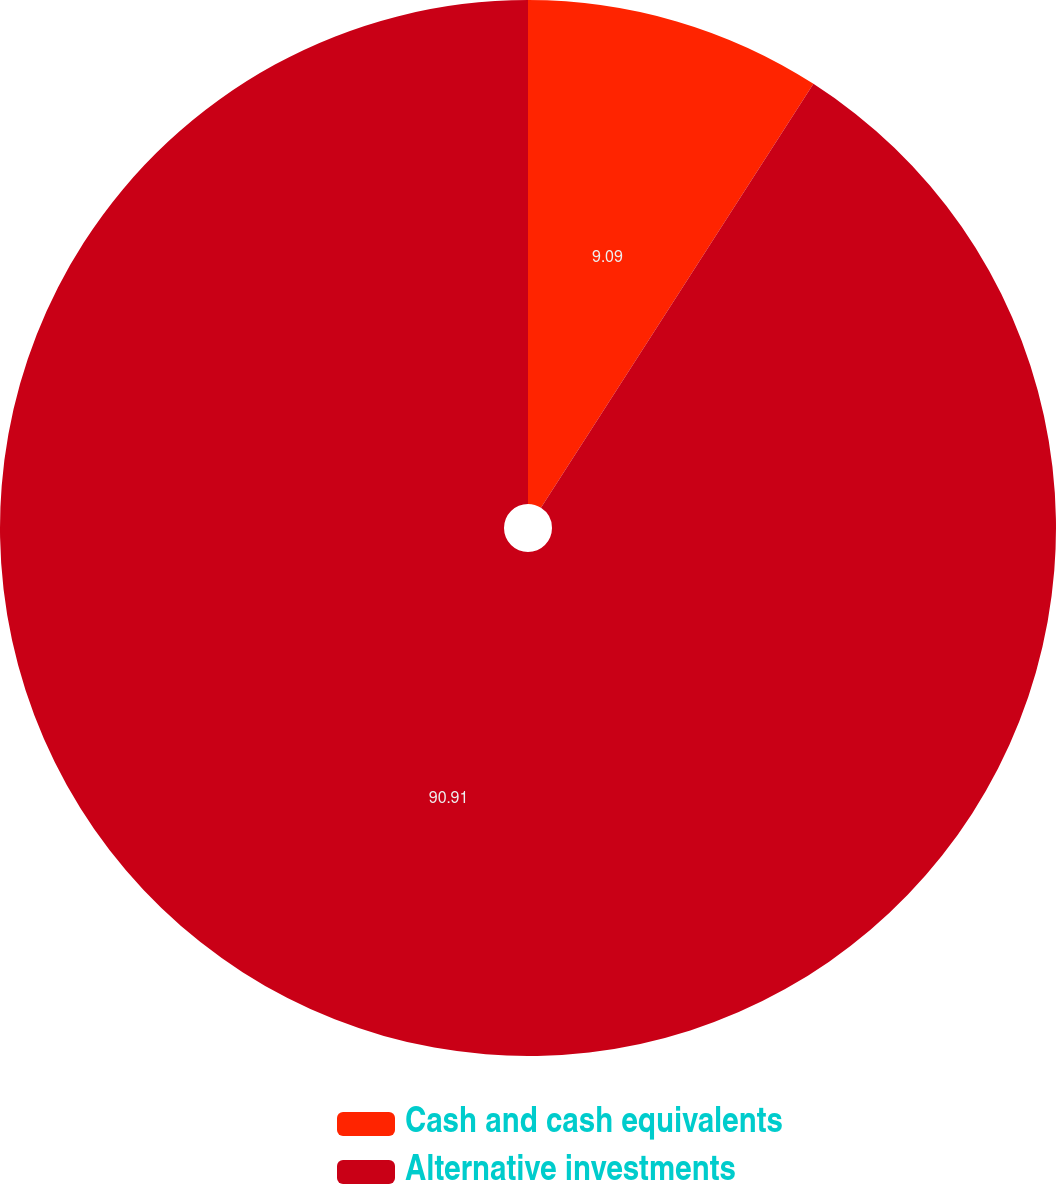Convert chart. <chart><loc_0><loc_0><loc_500><loc_500><pie_chart><fcel>Cash and cash equivalents<fcel>Alternative investments<nl><fcel>9.09%<fcel>90.91%<nl></chart> 